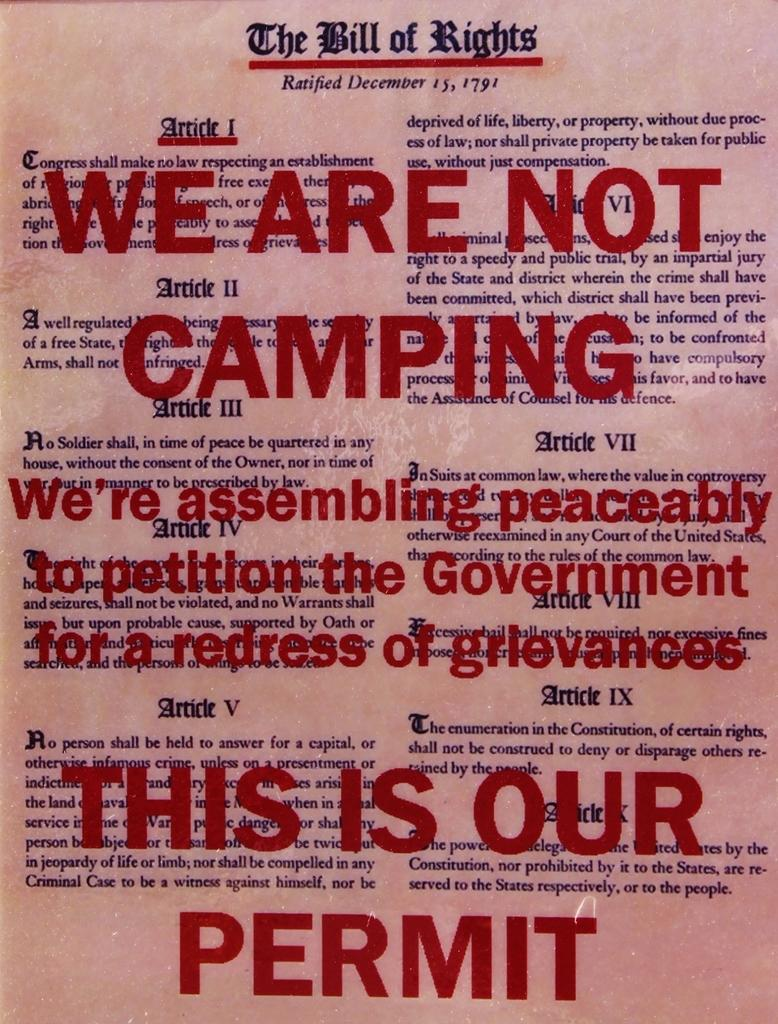<image>
Write a terse but informative summary of the picture. The Bill of Rights has large red text on it that says, in part, "this is our permit." 